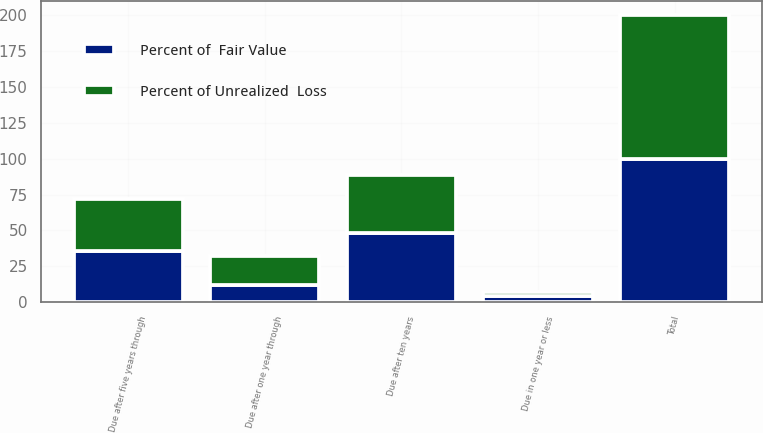Convert chart. <chart><loc_0><loc_0><loc_500><loc_500><stacked_bar_chart><ecel><fcel>Due in one year or less<fcel>Due after one year through<fcel>Due after five years through<fcel>Due after ten years<fcel>Total<nl><fcel>Percent of Unrealized  Loss<fcel>3<fcel>20<fcel>36<fcel>41<fcel>100<nl><fcel>Percent of  Fair Value<fcel>4<fcel>12<fcel>36<fcel>48<fcel>100<nl></chart> 